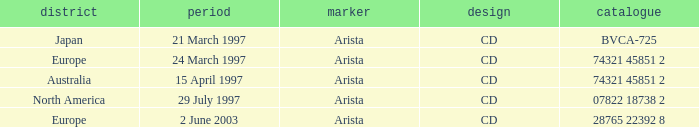What's the Date with the Region of Europe and has a Catalog of 28765 22392 8? 2 June 2003. 